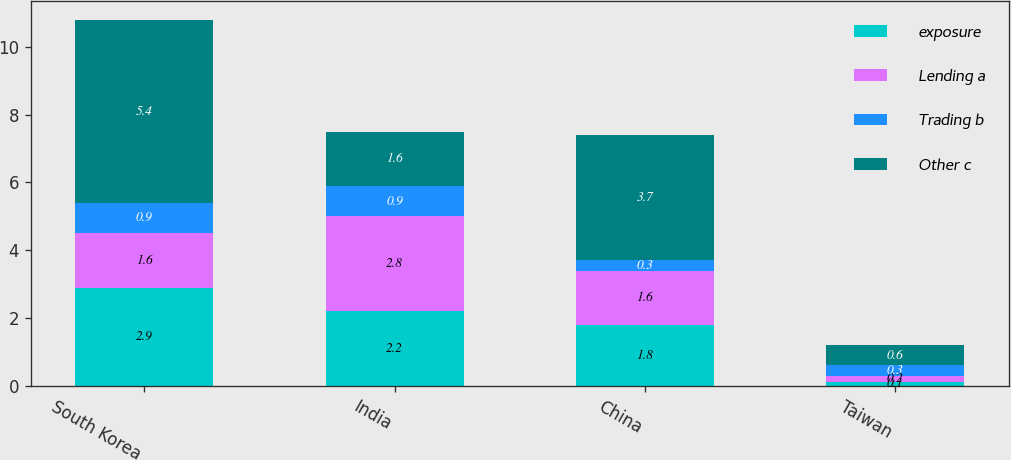<chart> <loc_0><loc_0><loc_500><loc_500><stacked_bar_chart><ecel><fcel>South Korea<fcel>India<fcel>China<fcel>Taiwan<nl><fcel>exposure<fcel>2.9<fcel>2.2<fcel>1.8<fcel>0.1<nl><fcel>Lending a<fcel>1.6<fcel>2.8<fcel>1.6<fcel>0.2<nl><fcel>Trading b<fcel>0.9<fcel>0.9<fcel>0.3<fcel>0.3<nl><fcel>Other c<fcel>5.4<fcel>1.6<fcel>3.7<fcel>0.6<nl></chart> 